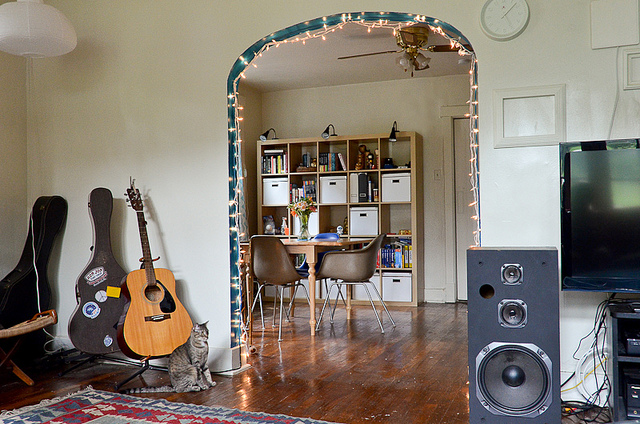<image>How much music will be made with the guitar? It is unanswerable how much music will be made with the guitar. How much music will be made with the guitar? I don't know how much music will be made with the guitar. It can be none, little, some or a lot. 